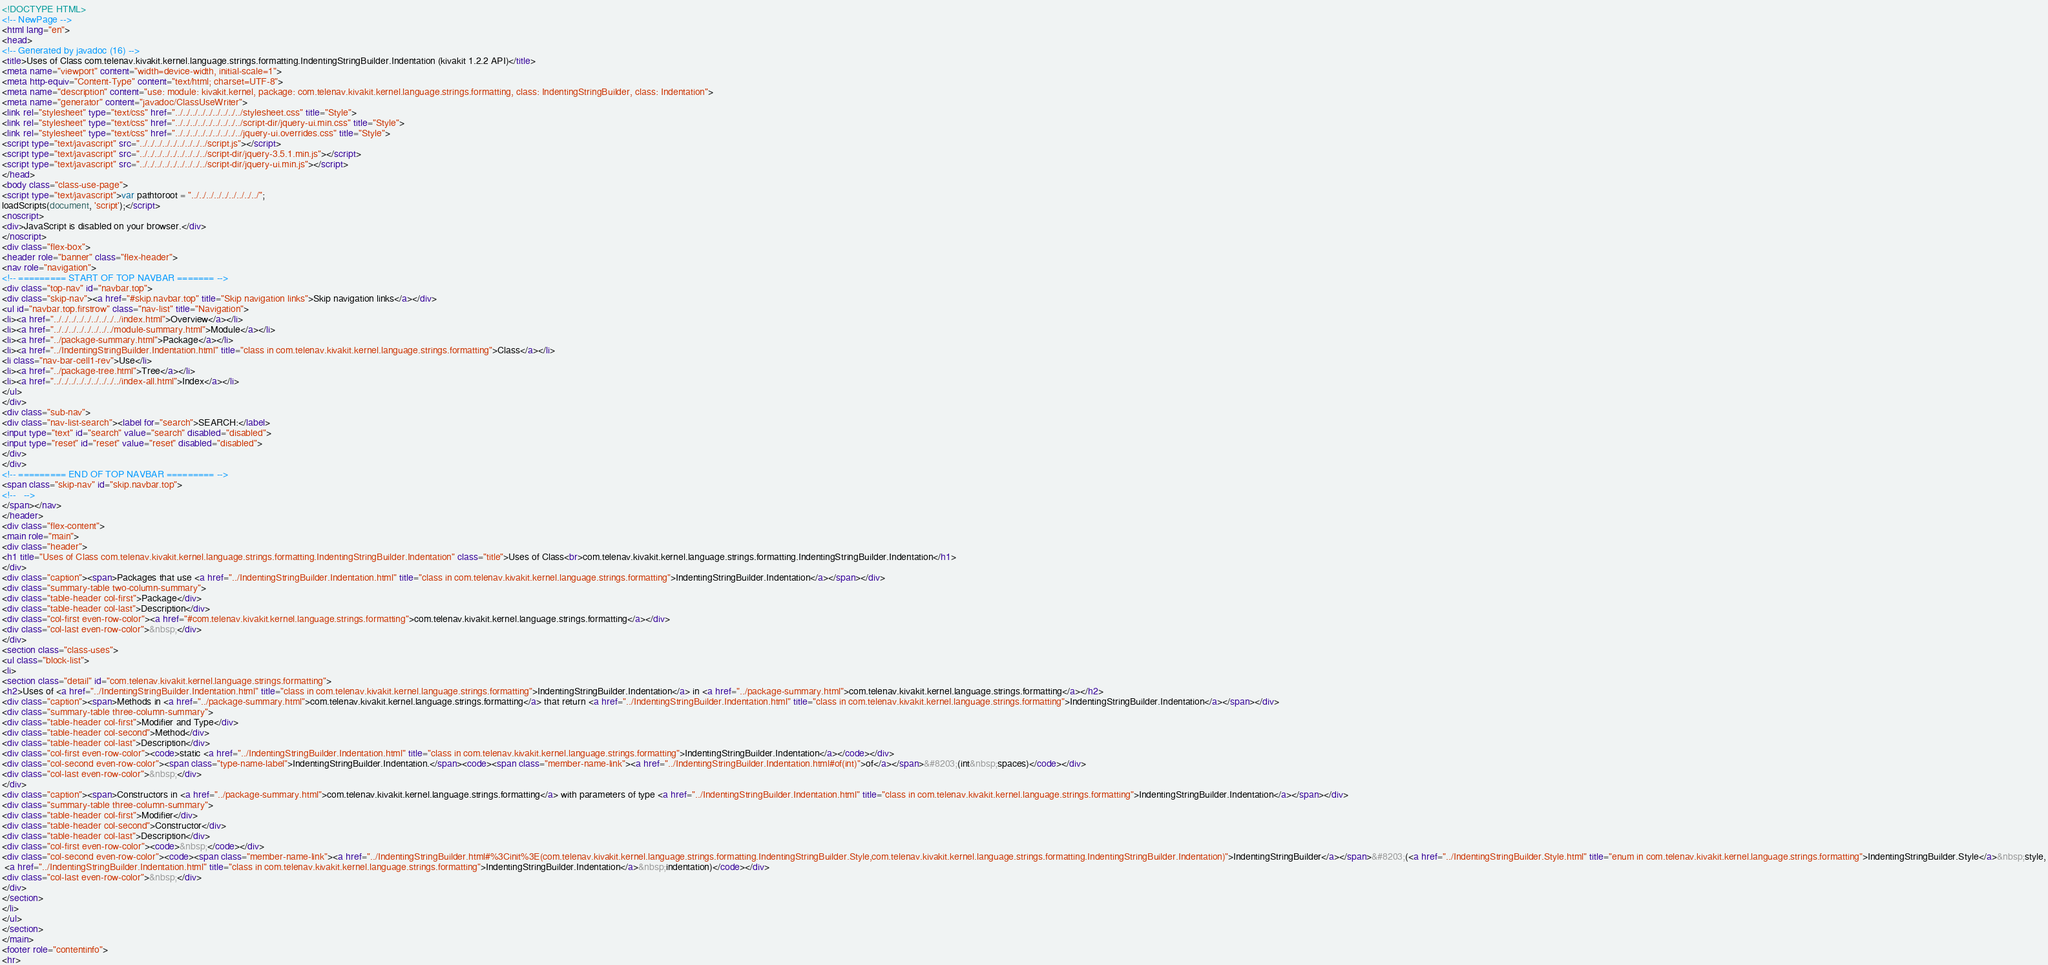Convert code to text. <code><loc_0><loc_0><loc_500><loc_500><_HTML_><!DOCTYPE HTML>
<!-- NewPage -->
<html lang="en">
<head>
<!-- Generated by javadoc (16) -->
<title>Uses of Class com.telenav.kivakit.kernel.language.strings.formatting.IndentingStringBuilder.Indentation (kivakit 1.2.2 API)</title>
<meta name="viewport" content="width=device-width, initial-scale=1">
<meta http-equiv="Content-Type" content="text/html; charset=UTF-8">
<meta name="description" content="use: module: kivakit.kernel, package: com.telenav.kivakit.kernel.language.strings.formatting, class: IndentingStringBuilder, class: Indentation">
<meta name="generator" content="javadoc/ClassUseWriter">
<link rel="stylesheet" type="text/css" href="../../../../../../../../../stylesheet.css" title="Style">
<link rel="stylesheet" type="text/css" href="../../../../../../../../../script-dir/jquery-ui.min.css" title="Style">
<link rel="stylesheet" type="text/css" href="../../../../../../../../../jquery-ui.overrides.css" title="Style">
<script type="text/javascript" src="../../../../../../../../../script.js"></script>
<script type="text/javascript" src="../../../../../../../../../script-dir/jquery-3.5.1.min.js"></script>
<script type="text/javascript" src="../../../../../../../../../script-dir/jquery-ui.min.js"></script>
</head>
<body class="class-use-page">
<script type="text/javascript">var pathtoroot = "../../../../../../../../../";
loadScripts(document, 'script');</script>
<noscript>
<div>JavaScript is disabled on your browser.</div>
</noscript>
<div class="flex-box">
<header role="banner" class="flex-header">
<nav role="navigation">
<!-- ========= START OF TOP NAVBAR ======= -->
<div class="top-nav" id="navbar.top">
<div class="skip-nav"><a href="#skip.navbar.top" title="Skip navigation links">Skip navigation links</a></div>
<ul id="navbar.top.firstrow" class="nav-list" title="Navigation">
<li><a href="../../../../../../../../../index.html">Overview</a></li>
<li><a href="../../../../../../../../module-summary.html">Module</a></li>
<li><a href="../package-summary.html">Package</a></li>
<li><a href="../IndentingStringBuilder.Indentation.html" title="class in com.telenav.kivakit.kernel.language.strings.formatting">Class</a></li>
<li class="nav-bar-cell1-rev">Use</li>
<li><a href="../package-tree.html">Tree</a></li>
<li><a href="../../../../../../../../../index-all.html">Index</a></li>
</ul>
</div>
<div class="sub-nav">
<div class="nav-list-search"><label for="search">SEARCH:</label>
<input type="text" id="search" value="search" disabled="disabled">
<input type="reset" id="reset" value="reset" disabled="disabled">
</div>
</div>
<!-- ========= END OF TOP NAVBAR ========= -->
<span class="skip-nav" id="skip.navbar.top">
<!--   -->
</span></nav>
</header>
<div class="flex-content">
<main role="main">
<div class="header">
<h1 title="Uses of Class com.telenav.kivakit.kernel.language.strings.formatting.IndentingStringBuilder.Indentation" class="title">Uses of Class<br>com.telenav.kivakit.kernel.language.strings.formatting.IndentingStringBuilder.Indentation</h1>
</div>
<div class="caption"><span>Packages that use <a href="../IndentingStringBuilder.Indentation.html" title="class in com.telenav.kivakit.kernel.language.strings.formatting">IndentingStringBuilder.Indentation</a></span></div>
<div class="summary-table two-column-summary">
<div class="table-header col-first">Package</div>
<div class="table-header col-last">Description</div>
<div class="col-first even-row-color"><a href="#com.telenav.kivakit.kernel.language.strings.formatting">com.telenav.kivakit.kernel.language.strings.formatting</a></div>
<div class="col-last even-row-color">&nbsp;</div>
</div>
<section class="class-uses">
<ul class="block-list">
<li>
<section class="detail" id="com.telenav.kivakit.kernel.language.strings.formatting">
<h2>Uses of <a href="../IndentingStringBuilder.Indentation.html" title="class in com.telenav.kivakit.kernel.language.strings.formatting">IndentingStringBuilder.Indentation</a> in <a href="../package-summary.html">com.telenav.kivakit.kernel.language.strings.formatting</a></h2>
<div class="caption"><span>Methods in <a href="../package-summary.html">com.telenav.kivakit.kernel.language.strings.formatting</a> that return <a href="../IndentingStringBuilder.Indentation.html" title="class in com.telenav.kivakit.kernel.language.strings.formatting">IndentingStringBuilder.Indentation</a></span></div>
<div class="summary-table three-column-summary">
<div class="table-header col-first">Modifier and Type</div>
<div class="table-header col-second">Method</div>
<div class="table-header col-last">Description</div>
<div class="col-first even-row-color"><code>static <a href="../IndentingStringBuilder.Indentation.html" title="class in com.telenav.kivakit.kernel.language.strings.formatting">IndentingStringBuilder.Indentation</a></code></div>
<div class="col-second even-row-color"><span class="type-name-label">IndentingStringBuilder.Indentation.</span><code><span class="member-name-link"><a href="../IndentingStringBuilder.Indentation.html#of(int)">of</a></span>&#8203;(int&nbsp;spaces)</code></div>
<div class="col-last even-row-color">&nbsp;</div>
</div>
<div class="caption"><span>Constructors in <a href="../package-summary.html">com.telenav.kivakit.kernel.language.strings.formatting</a> with parameters of type <a href="../IndentingStringBuilder.Indentation.html" title="class in com.telenav.kivakit.kernel.language.strings.formatting">IndentingStringBuilder.Indentation</a></span></div>
<div class="summary-table three-column-summary">
<div class="table-header col-first">Modifier</div>
<div class="table-header col-second">Constructor</div>
<div class="table-header col-last">Description</div>
<div class="col-first even-row-color"><code>&nbsp;</code></div>
<div class="col-second even-row-color"><code><span class="member-name-link"><a href="../IndentingStringBuilder.html#%3Cinit%3E(com.telenav.kivakit.kernel.language.strings.formatting.IndentingStringBuilder.Style,com.telenav.kivakit.kernel.language.strings.formatting.IndentingStringBuilder.Indentation)">IndentingStringBuilder</a></span>&#8203;(<a href="../IndentingStringBuilder.Style.html" title="enum in com.telenav.kivakit.kernel.language.strings.formatting">IndentingStringBuilder.Style</a>&nbsp;style,
 <a href="../IndentingStringBuilder.Indentation.html" title="class in com.telenav.kivakit.kernel.language.strings.formatting">IndentingStringBuilder.Indentation</a>&nbsp;indentation)</code></div>
<div class="col-last even-row-color">&nbsp;</div>
</div>
</section>
</li>
</ul>
</section>
</main>
<footer role="contentinfo">
<hr></code> 